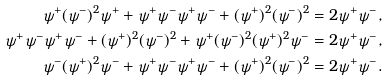<formula> <loc_0><loc_0><loc_500><loc_500>\psi ^ { + } ( \psi ^ { - } ) ^ { 2 } \psi ^ { + } + \psi ^ { + } \psi ^ { - } \psi ^ { + } \psi ^ { - } + ( \psi ^ { + } ) ^ { 2 } ( \psi ^ { - } ) ^ { 2 } & = 2 \psi ^ { + } \psi ^ { - } , \\ \psi ^ { + } \psi ^ { - } \psi ^ { + } \psi ^ { - } + ( \psi ^ { + } ) ^ { 2 } ( \psi ^ { - } ) ^ { 2 } + \psi ^ { + } ( \psi ^ { - } ) ^ { 2 } ( \psi ^ { + } ) ^ { 2 } \psi ^ { - } & = 2 \psi ^ { + } \psi ^ { - } , \\ \psi ^ { - } ( \psi ^ { + } ) ^ { 2 } \psi ^ { - } + \psi ^ { + } \psi ^ { - } \psi ^ { + } \psi ^ { - } + ( \psi ^ { + } ) ^ { 2 } ( \psi ^ { - } ) ^ { 2 } & = 2 \psi ^ { + } \psi ^ { - } .</formula> 